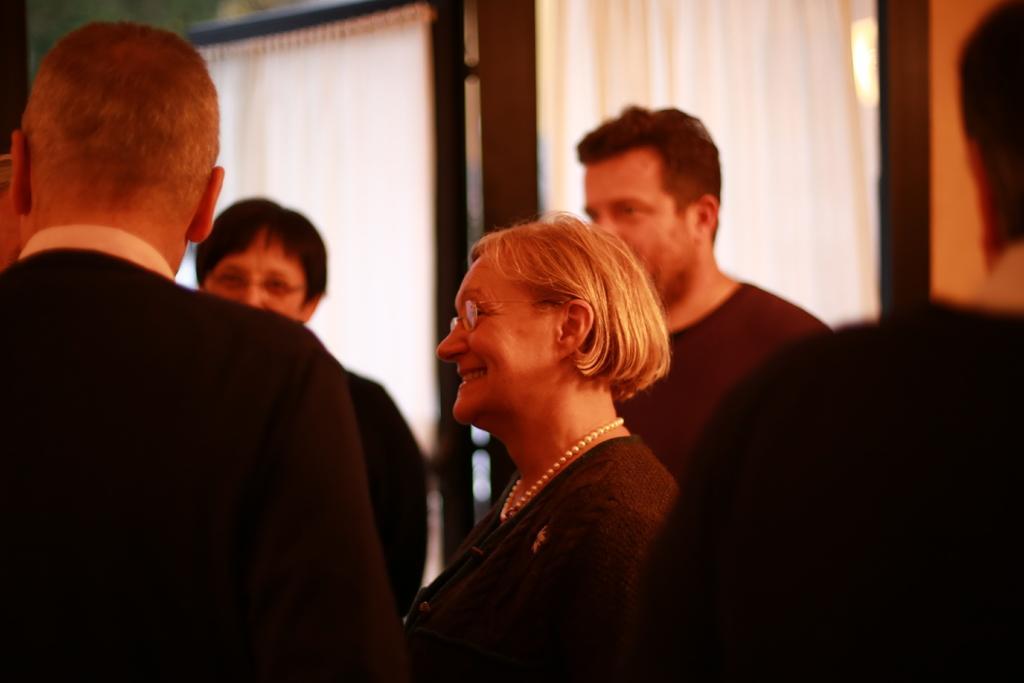Could you give a brief overview of what you see in this image? Here men and women are standing wearing black color clothes. 